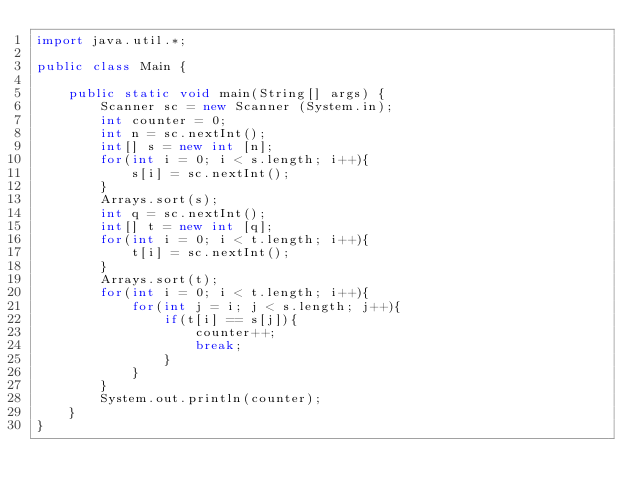Convert code to text. <code><loc_0><loc_0><loc_500><loc_500><_Java_>import java.util.*;

public class Main {

	public static void main(String[] args) {
		Scanner sc = new Scanner (System.in);
		int counter = 0;
		int n = sc.nextInt();
		int[] s = new int [n];
		for(int i = 0; i < s.length; i++){
			s[i] = sc.nextInt();
		}
		Arrays.sort(s);
		int q = sc.nextInt();
		int[] t = new int [q];
		for(int i = 0; i < t.length; i++){
			t[i] = sc.nextInt();
		}
		Arrays.sort(t);
		for(int i = 0; i < t.length; i++){
			for(int j = i; j < s.length; j++){
				if(t[i] == s[j]){
					counter++;
					break;
				}
			}
		}
		System.out.println(counter);
	}
}</code> 